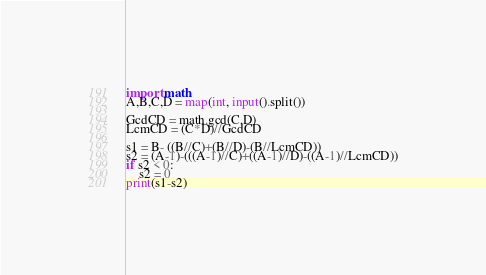Convert code to text. <code><loc_0><loc_0><loc_500><loc_500><_Python_>import math
A,B,C,D = map(int, input().split())

GcdCD = math.gcd(C,D)
LcmCD = (C*D)//GcdCD

s1 = B- ((B//C)+(B//D)-(B//LcmCD))
s2 = (A-1)-(((A-1)//C)+((A-1)//D)-((A-1)//LcmCD))
if s2 < 0:
    s2 = 0
print(s1-s2)</code> 